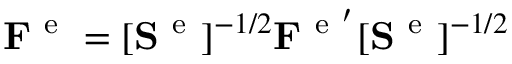<formula> <loc_0><loc_0><loc_500><loc_500>\begin{array} { r } { F ^ { e } = [ S ^ { e } ] ^ { - 1 / 2 } F ^ { e ^ { \prime } } [ S ^ { e } ] ^ { - 1 / 2 } } \end{array}</formula> 